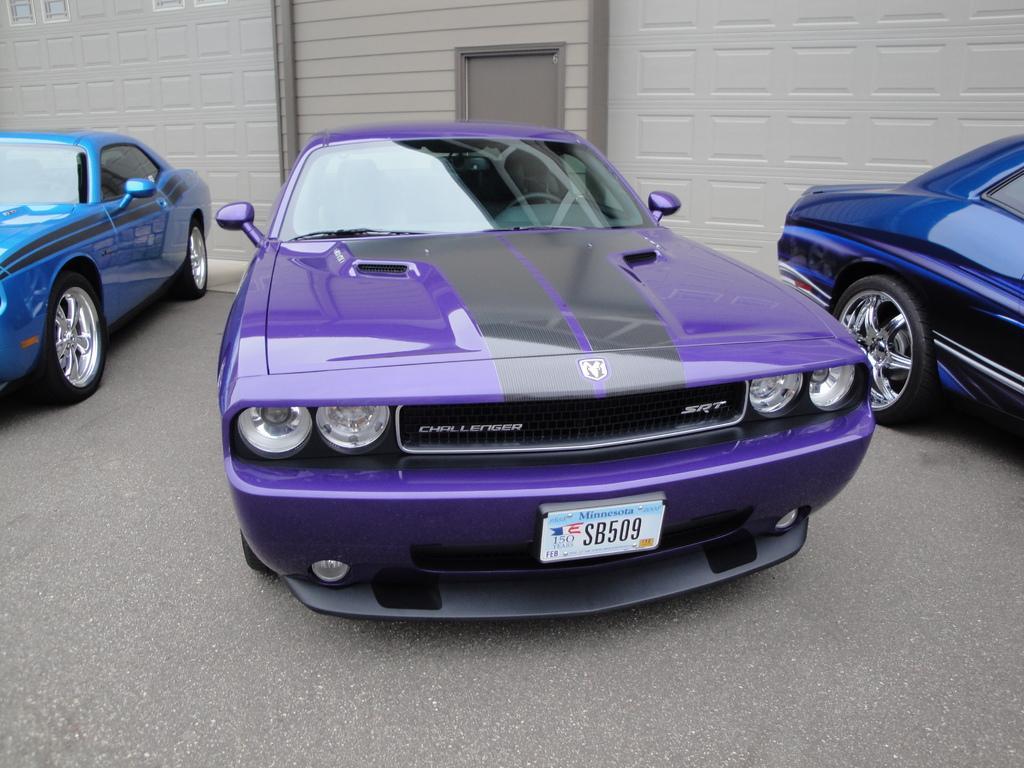In one or two sentences, can you explain what this image depicts? In this image there are cars, there are windows and a door of the building. 